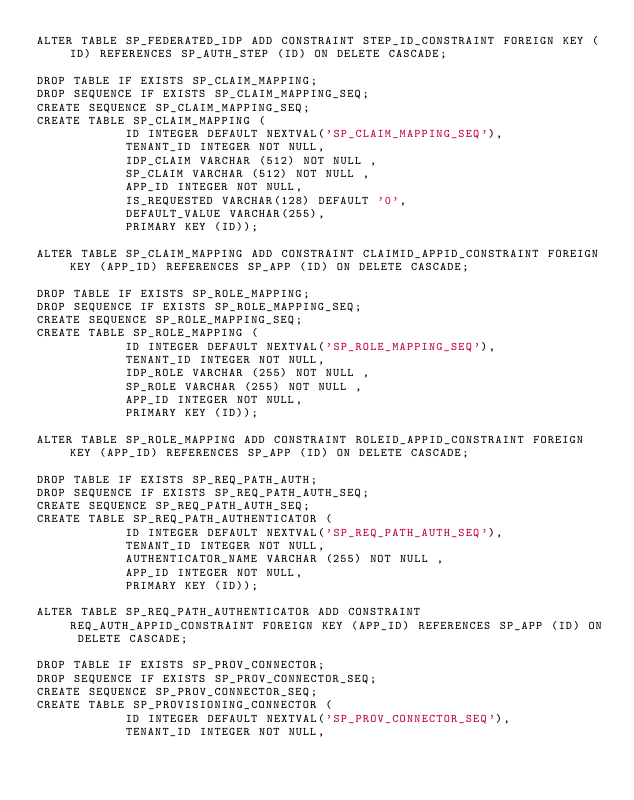Convert code to text. <code><loc_0><loc_0><loc_500><loc_500><_SQL_>ALTER TABLE SP_FEDERATED_IDP ADD CONSTRAINT STEP_ID_CONSTRAINT FOREIGN KEY (ID) REFERENCES SP_AUTH_STEP (ID) ON DELETE CASCADE;

DROP TABLE IF EXISTS SP_CLAIM_MAPPING;
DROP SEQUENCE IF EXISTS SP_CLAIM_MAPPING_SEQ;
CREATE SEQUENCE SP_CLAIM_MAPPING_SEQ;
CREATE TABLE SP_CLAIM_MAPPING (
	    	ID INTEGER DEFAULT NEXTVAL('SP_CLAIM_MAPPING_SEQ'),
	    	TENANT_ID INTEGER NOT NULL,
	    	IDP_CLAIM VARCHAR (512) NOT NULL ,
            SP_CLAIM VARCHAR (512) NOT NULL ,
	   		APP_ID INTEGER NOT NULL,
	    	IS_REQUESTED VARCHAR(128) DEFAULT '0',
	    	DEFAULT_VALUE VARCHAR(255),
            PRIMARY KEY (ID));

ALTER TABLE SP_CLAIM_MAPPING ADD CONSTRAINT CLAIMID_APPID_CONSTRAINT FOREIGN KEY (APP_ID) REFERENCES SP_APP (ID) ON DELETE CASCADE;

DROP TABLE IF EXISTS SP_ROLE_MAPPING;
DROP SEQUENCE IF EXISTS SP_ROLE_MAPPING_SEQ;
CREATE SEQUENCE SP_ROLE_MAPPING_SEQ;
CREATE TABLE SP_ROLE_MAPPING (
	    	ID INTEGER DEFAULT NEXTVAL('SP_ROLE_MAPPING_SEQ'),
	    	TENANT_ID INTEGER NOT NULL,
	    	IDP_ROLE VARCHAR (255) NOT NULL ,
            SP_ROLE VARCHAR (255) NOT NULL ,
	    	APP_ID INTEGER NOT NULL,
            PRIMARY KEY (ID));

ALTER TABLE SP_ROLE_MAPPING ADD CONSTRAINT ROLEID_APPID_CONSTRAINT FOREIGN KEY (APP_ID) REFERENCES SP_APP (ID) ON DELETE CASCADE;

DROP TABLE IF EXISTS SP_REQ_PATH_AUTH;
DROP SEQUENCE IF EXISTS SP_REQ_PATH_AUTH_SEQ;
CREATE SEQUENCE SP_REQ_PATH_AUTH_SEQ;
CREATE TABLE SP_REQ_PATH_AUTHENTICATOR (
	    	ID INTEGER DEFAULT NEXTVAL('SP_REQ_PATH_AUTH_SEQ'),
	    	TENANT_ID INTEGER NOT NULL,
	    	AUTHENTICATOR_NAME VARCHAR (255) NOT NULL ,
	    	APP_ID INTEGER NOT NULL,
            PRIMARY KEY (ID));

ALTER TABLE SP_REQ_PATH_AUTHENTICATOR ADD CONSTRAINT REQ_AUTH_APPID_CONSTRAINT FOREIGN KEY (APP_ID) REFERENCES SP_APP (ID) ON DELETE CASCADE;

DROP TABLE IF EXISTS SP_PROV_CONNECTOR;
DROP SEQUENCE IF EXISTS SP_PROV_CONNECTOR_SEQ;
CREATE SEQUENCE SP_PROV_CONNECTOR_SEQ;
CREATE TABLE SP_PROVISIONING_CONNECTOR (
	    	ID INTEGER DEFAULT NEXTVAL('SP_PROV_CONNECTOR_SEQ'),
	    	TENANT_ID INTEGER NOT NULL,</code> 